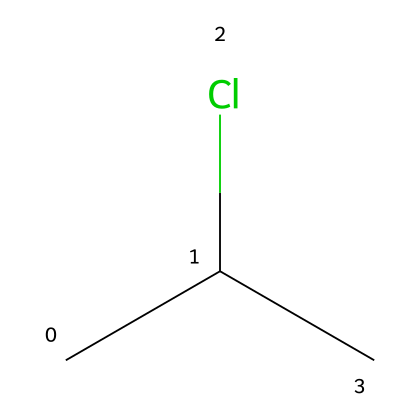What is the main element present in this chemical? The SMILES representation shows the presence of chlorine (Cl) and carbon (C) atoms. The presence of 'Cl' indicates that chlorine is a major component.
Answer: chlorine How many carbon atoms are in the chemical structure? The SMILES indicates two carbon atoms ('C' is followed by another 'C' in the chain), confirming there are two carbon atoms in total.
Answer: 2 What type of functional group is represented by the 'Cl' in this chemical? The presence of 'Cl' signifies a halogen functional group, specifically, a chloro group. This is characteristic of organohalides.
Answer: chloro Is this chemical polar or nonpolar? The presence of chlorine, which is more electronegative than carbon, suggests a difference in charge distribution creating polar characteristics in the molecule.
Answer: polar What is the primary use of this chemical in water distribution systems? PVC, represented by this chemical structure, is primarily used for its strength and resistance to corrosion making it suitable for pipes in water distribution systems.
Answer: pipes How does the presence of chlorine affect the properties of this chemical? The chlorine atom introduces enhanced durability and resistance to chemicals, making the polymer useful in applications like plumbing where longevity is important.
Answer: enhances durability 